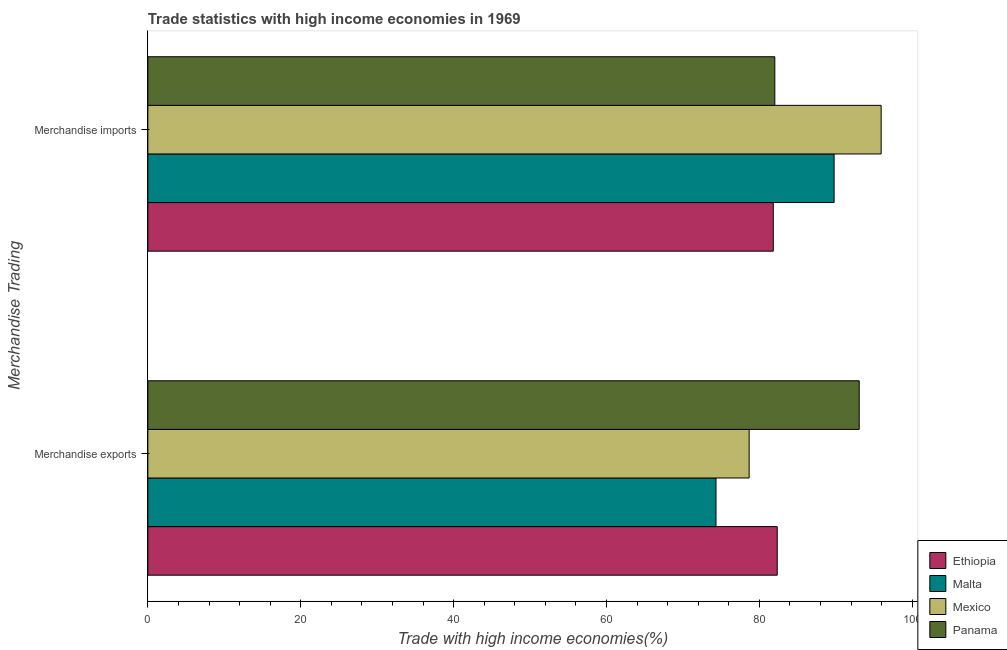How many different coloured bars are there?
Offer a terse response. 4. Are the number of bars per tick equal to the number of legend labels?
Your response must be concise. Yes. How many bars are there on the 1st tick from the top?
Offer a very short reply. 4. How many bars are there on the 2nd tick from the bottom?
Provide a succinct answer. 4. What is the label of the 1st group of bars from the top?
Ensure brevity in your answer.  Merchandise imports. What is the merchandise imports in Malta?
Provide a succinct answer. 89.77. Across all countries, what is the maximum merchandise exports?
Give a very brief answer. 93.06. Across all countries, what is the minimum merchandise imports?
Your answer should be very brief. 81.82. In which country was the merchandise imports maximum?
Your response must be concise. Mexico. In which country was the merchandise imports minimum?
Ensure brevity in your answer.  Ethiopia. What is the total merchandise imports in the graph?
Your answer should be very brief. 349.53. What is the difference between the merchandise exports in Panama and that in Malta?
Provide a succinct answer. 18.74. What is the difference between the merchandise imports in Panama and the merchandise exports in Malta?
Your answer should be very brief. 7.69. What is the average merchandise exports per country?
Keep it short and to the point. 82.09. What is the difference between the merchandise imports and merchandise exports in Malta?
Ensure brevity in your answer.  15.45. What is the ratio of the merchandise imports in Panama to that in Mexico?
Your answer should be very brief. 0.85. In how many countries, is the merchandise exports greater than the average merchandise exports taken over all countries?
Offer a terse response. 2. What does the 3rd bar from the top in Merchandise imports represents?
Provide a succinct answer. Malta. What does the 4th bar from the bottom in Merchandise imports represents?
Provide a short and direct response. Panama. How many bars are there?
Your answer should be compact. 8. How many countries are there in the graph?
Offer a terse response. 4. Does the graph contain any zero values?
Ensure brevity in your answer.  No. Does the graph contain grids?
Provide a succinct answer. No. Where does the legend appear in the graph?
Your answer should be very brief. Bottom right. What is the title of the graph?
Give a very brief answer. Trade statistics with high income economies in 1969. What is the label or title of the X-axis?
Give a very brief answer. Trade with high income economies(%). What is the label or title of the Y-axis?
Ensure brevity in your answer.  Merchandise Trading. What is the Trade with high income economies(%) in Ethiopia in Merchandise exports?
Keep it short and to the point. 82.33. What is the Trade with high income economies(%) of Malta in Merchandise exports?
Provide a short and direct response. 74.32. What is the Trade with high income economies(%) of Mexico in Merchandise exports?
Make the answer very short. 78.66. What is the Trade with high income economies(%) in Panama in Merchandise exports?
Your answer should be very brief. 93.06. What is the Trade with high income economies(%) of Ethiopia in Merchandise imports?
Your response must be concise. 81.82. What is the Trade with high income economies(%) in Malta in Merchandise imports?
Provide a short and direct response. 89.77. What is the Trade with high income economies(%) of Mexico in Merchandise imports?
Provide a short and direct response. 95.93. What is the Trade with high income economies(%) of Panama in Merchandise imports?
Keep it short and to the point. 82.01. Across all Merchandise Trading, what is the maximum Trade with high income economies(%) in Ethiopia?
Offer a very short reply. 82.33. Across all Merchandise Trading, what is the maximum Trade with high income economies(%) in Malta?
Provide a succinct answer. 89.77. Across all Merchandise Trading, what is the maximum Trade with high income economies(%) of Mexico?
Give a very brief answer. 95.93. Across all Merchandise Trading, what is the maximum Trade with high income economies(%) in Panama?
Offer a very short reply. 93.06. Across all Merchandise Trading, what is the minimum Trade with high income economies(%) of Ethiopia?
Ensure brevity in your answer.  81.82. Across all Merchandise Trading, what is the minimum Trade with high income economies(%) of Malta?
Your answer should be very brief. 74.32. Across all Merchandise Trading, what is the minimum Trade with high income economies(%) in Mexico?
Offer a terse response. 78.66. Across all Merchandise Trading, what is the minimum Trade with high income economies(%) in Panama?
Offer a very short reply. 82.01. What is the total Trade with high income economies(%) in Ethiopia in the graph?
Provide a succinct answer. 164.15. What is the total Trade with high income economies(%) in Malta in the graph?
Your response must be concise. 164.09. What is the total Trade with high income economies(%) in Mexico in the graph?
Your response must be concise. 174.58. What is the total Trade with high income economies(%) in Panama in the graph?
Provide a short and direct response. 175.07. What is the difference between the Trade with high income economies(%) in Ethiopia in Merchandise exports and that in Merchandise imports?
Offer a terse response. 0.52. What is the difference between the Trade with high income economies(%) of Malta in Merchandise exports and that in Merchandise imports?
Provide a short and direct response. -15.45. What is the difference between the Trade with high income economies(%) of Mexico in Merchandise exports and that in Merchandise imports?
Offer a terse response. -17.27. What is the difference between the Trade with high income economies(%) of Panama in Merchandise exports and that in Merchandise imports?
Your response must be concise. 11.04. What is the difference between the Trade with high income economies(%) in Ethiopia in Merchandise exports and the Trade with high income economies(%) in Malta in Merchandise imports?
Keep it short and to the point. -7.44. What is the difference between the Trade with high income economies(%) of Ethiopia in Merchandise exports and the Trade with high income economies(%) of Mexico in Merchandise imports?
Keep it short and to the point. -13.59. What is the difference between the Trade with high income economies(%) in Ethiopia in Merchandise exports and the Trade with high income economies(%) in Panama in Merchandise imports?
Offer a very short reply. 0.32. What is the difference between the Trade with high income economies(%) in Malta in Merchandise exports and the Trade with high income economies(%) in Mexico in Merchandise imports?
Keep it short and to the point. -21.61. What is the difference between the Trade with high income economies(%) of Malta in Merchandise exports and the Trade with high income economies(%) of Panama in Merchandise imports?
Provide a succinct answer. -7.69. What is the difference between the Trade with high income economies(%) in Mexico in Merchandise exports and the Trade with high income economies(%) in Panama in Merchandise imports?
Ensure brevity in your answer.  -3.36. What is the average Trade with high income economies(%) in Ethiopia per Merchandise Trading?
Give a very brief answer. 82.07. What is the average Trade with high income economies(%) of Malta per Merchandise Trading?
Your answer should be compact. 82.05. What is the average Trade with high income economies(%) in Mexico per Merchandise Trading?
Your answer should be compact. 87.29. What is the average Trade with high income economies(%) of Panama per Merchandise Trading?
Provide a short and direct response. 87.54. What is the difference between the Trade with high income economies(%) in Ethiopia and Trade with high income economies(%) in Malta in Merchandise exports?
Your response must be concise. 8.01. What is the difference between the Trade with high income economies(%) of Ethiopia and Trade with high income economies(%) of Mexico in Merchandise exports?
Provide a short and direct response. 3.68. What is the difference between the Trade with high income economies(%) of Ethiopia and Trade with high income economies(%) of Panama in Merchandise exports?
Offer a terse response. -10.73. What is the difference between the Trade with high income economies(%) in Malta and Trade with high income economies(%) in Mexico in Merchandise exports?
Keep it short and to the point. -4.34. What is the difference between the Trade with high income economies(%) of Malta and Trade with high income economies(%) of Panama in Merchandise exports?
Give a very brief answer. -18.74. What is the difference between the Trade with high income economies(%) of Mexico and Trade with high income economies(%) of Panama in Merchandise exports?
Your answer should be compact. -14.4. What is the difference between the Trade with high income economies(%) of Ethiopia and Trade with high income economies(%) of Malta in Merchandise imports?
Your answer should be very brief. -7.96. What is the difference between the Trade with high income economies(%) in Ethiopia and Trade with high income economies(%) in Mexico in Merchandise imports?
Offer a very short reply. -14.11. What is the difference between the Trade with high income economies(%) of Ethiopia and Trade with high income economies(%) of Panama in Merchandise imports?
Provide a succinct answer. -0.2. What is the difference between the Trade with high income economies(%) in Malta and Trade with high income economies(%) in Mexico in Merchandise imports?
Offer a terse response. -6.16. What is the difference between the Trade with high income economies(%) in Malta and Trade with high income economies(%) in Panama in Merchandise imports?
Ensure brevity in your answer.  7.76. What is the difference between the Trade with high income economies(%) in Mexico and Trade with high income economies(%) in Panama in Merchandise imports?
Your answer should be compact. 13.91. What is the ratio of the Trade with high income economies(%) of Ethiopia in Merchandise exports to that in Merchandise imports?
Your response must be concise. 1.01. What is the ratio of the Trade with high income economies(%) in Malta in Merchandise exports to that in Merchandise imports?
Give a very brief answer. 0.83. What is the ratio of the Trade with high income economies(%) of Mexico in Merchandise exports to that in Merchandise imports?
Keep it short and to the point. 0.82. What is the ratio of the Trade with high income economies(%) in Panama in Merchandise exports to that in Merchandise imports?
Make the answer very short. 1.13. What is the difference between the highest and the second highest Trade with high income economies(%) in Ethiopia?
Ensure brevity in your answer.  0.52. What is the difference between the highest and the second highest Trade with high income economies(%) of Malta?
Provide a succinct answer. 15.45. What is the difference between the highest and the second highest Trade with high income economies(%) in Mexico?
Give a very brief answer. 17.27. What is the difference between the highest and the second highest Trade with high income economies(%) of Panama?
Provide a succinct answer. 11.04. What is the difference between the highest and the lowest Trade with high income economies(%) in Ethiopia?
Your answer should be compact. 0.52. What is the difference between the highest and the lowest Trade with high income economies(%) of Malta?
Ensure brevity in your answer.  15.45. What is the difference between the highest and the lowest Trade with high income economies(%) of Mexico?
Ensure brevity in your answer.  17.27. What is the difference between the highest and the lowest Trade with high income economies(%) of Panama?
Provide a succinct answer. 11.04. 